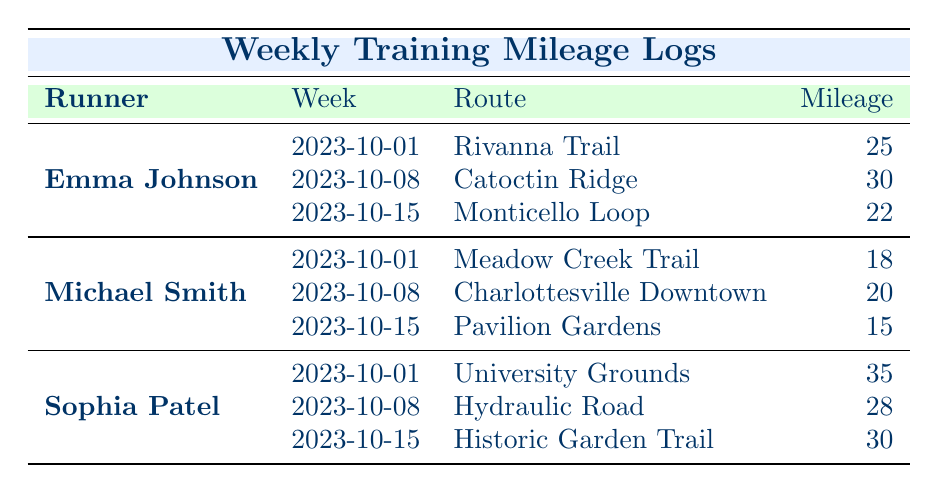What mileage did Emma Johnson run on 2023-10-08? According to the table, Emma Johnson's mileage for the week of 2023-10-08 is listed under her name. The specific route for that week is Catoctin Ridge, and the mileage is recorded as 30.
Answer: 30 What is the total mileage run by Michael Smith over the three weeks? To find Michael Smith's total mileage, we add together the mileage for each week: 18 (2023-10-01) + 20 (2023-10-08) + 15 (2023-10-15) = 53. Thus, his total mileage over the three weeks is 53.
Answer: 53 Did Sophia run more than 30 miles in the week of 2023-10-01? By looking at Sophia Patel's mileage for the week of 2023-10-01, the table indicates she ran 35 miles. Since 35 is greater than 30, the answer is yes.
Answer: Yes What was the lowest weekly mileage recorded for any runner? To find the lowest weekly mileage, we can look through the entire table. The mileage values are 25, 30, 22 (Emma), 18, 20, 15 (Michael), and 35, 28, 30 (Sophia). The lowest value among these is 15, which occurred for Michael Smith on 2023-10-15.
Answer: 15 Which runner had the highest average weekly mileage over the three weeks? First, we calculate the average weekly mileage for each runner. Emma: (25 + 30 + 22) / 3 = 25.67, Michael: (18 + 20 + 15) / 3 = 17.67, Sophia: (35 + 28 + 30) / 3 = 31. Thus, Sophia Patel has the highest average mileage of 31.
Answer: Sophia Patel What route did Michael run in the week of 2023-10-08? Referring to the table, during the week of 2023-10-08, Michael Smith ran the route called Charlottesville Downtown.
Answer: Charlottesville Downtown How many miles did Sophia run in total during the week of 2023-10-15? The table shows that Sophia Patel ran 30 miles during the week of 2023-10-15. Therefore, she ran 30 miles that week.
Answer: 30 Is there a week where Emma's mileage was lower than Michael's? By checking each week, we find that in week 2023-10-15, Emma ran 22 miles while Michael ran 15 miles, making Emma’s mileage higher. Since she never had lower mileage than Michael's in any week, the answer is no.
Answer: No 